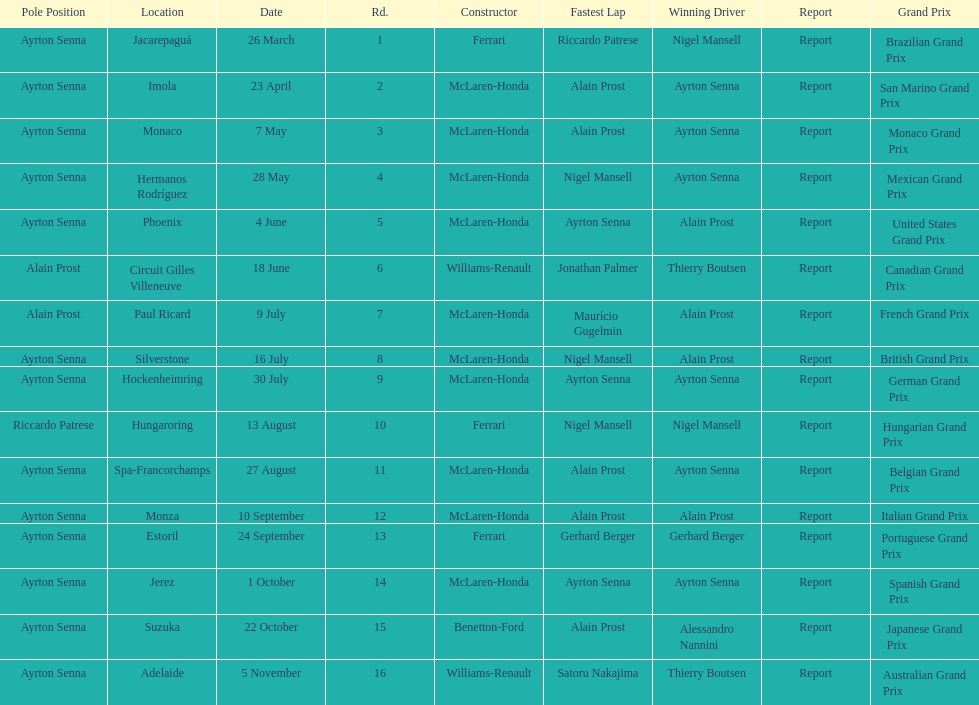How many did alain prost have the fastest lap? 5. 